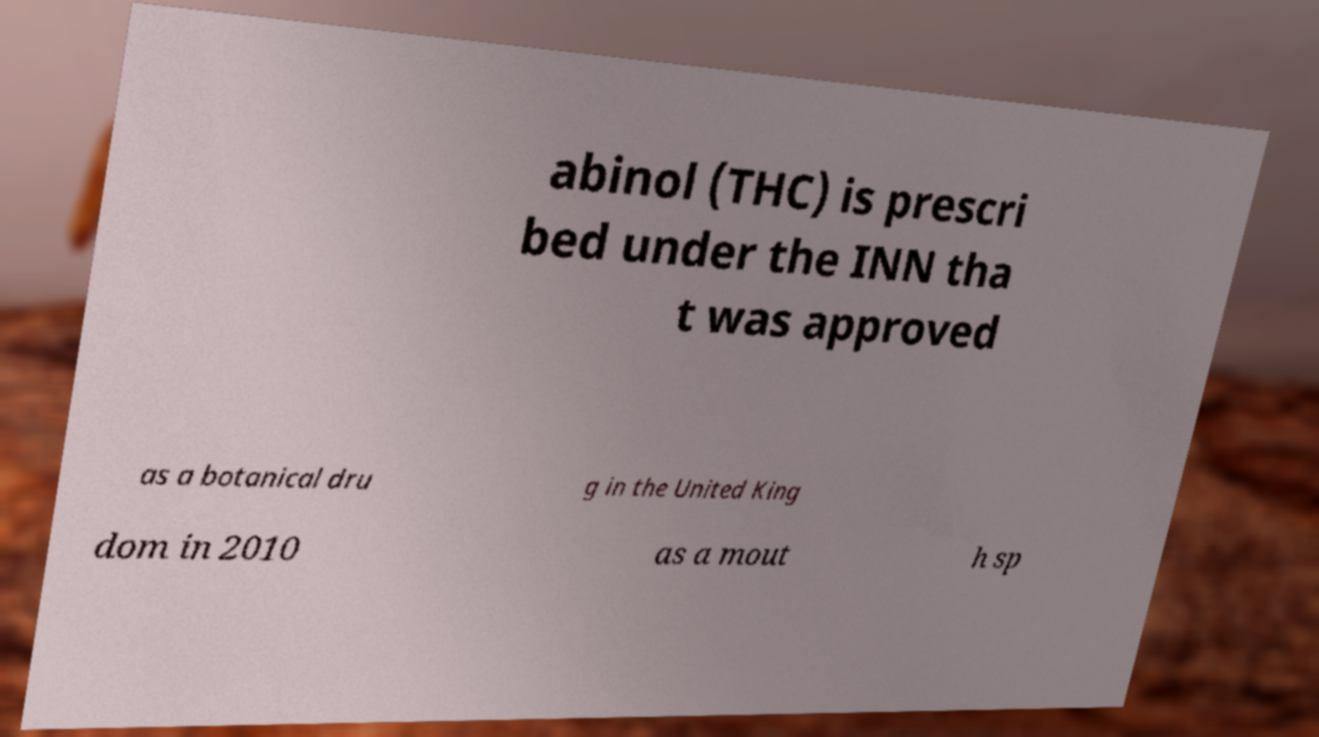For documentation purposes, I need the text within this image transcribed. Could you provide that? abinol (THC) is prescri bed under the INN tha t was approved as a botanical dru g in the United King dom in 2010 as a mout h sp 